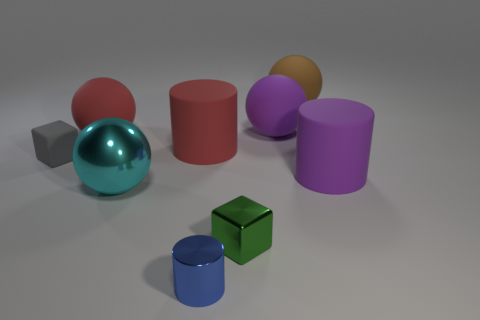Subtract 1 spheres. How many spheres are left? 3 Subtract all gray spheres. Subtract all yellow cylinders. How many spheres are left? 4 Subtract all cylinders. How many objects are left? 6 Add 3 blue cylinders. How many blue cylinders are left? 4 Add 6 gray matte things. How many gray matte things exist? 7 Subtract 0 yellow cubes. How many objects are left? 9 Subtract all green metal things. Subtract all small yellow balls. How many objects are left? 8 